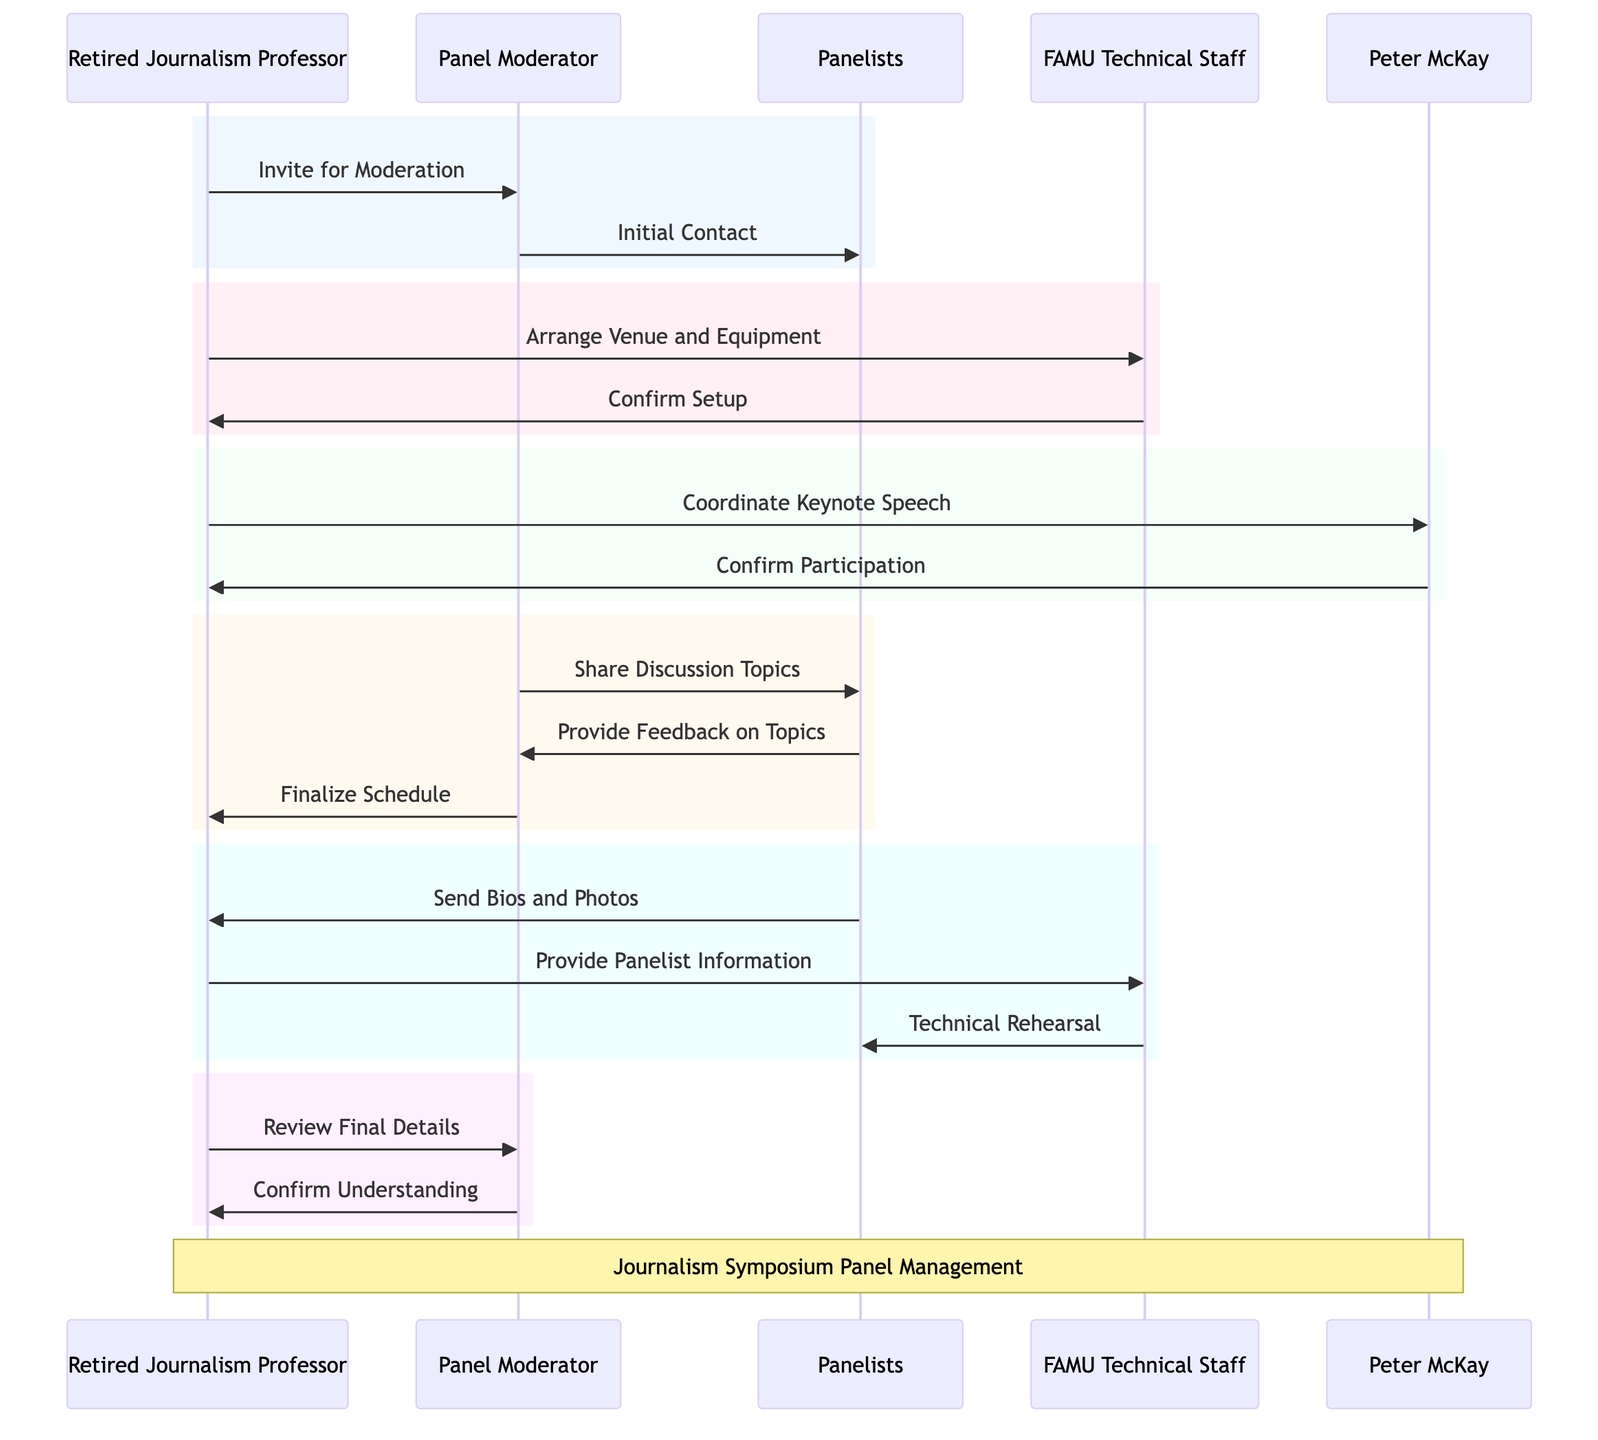What is the role of Peter McKay in the diagram? The diagram indicates that Peter McKay's role is as the Keynote Speaker. This is shown directly in the actor representation within the diagram where each individual's role is clearly stated.
Answer: Keynote Speaker How many participants are involved in the panel discussion? The diagram lists five key actors: Retired Journalism Professor, Panel Moderator, Panelists, FAMU Technical Staff, and Peter McKay. Counting these actors gives a total of five participants.
Answer: Five Who sends the initial contact to the panelists? According to the flow of the diagram, the Panel Moderator is responsible for making the initial contact with the Panelists. This action is shown as a direct message from the Panel Moderator to the Panelists labeled "Initial Contact."
Answer: Panel Moderator What is confirmed after the Retired Journalism Professor coordinates with Peter McKay? Following coordination with Peter McKay, the action labeled "Confirm Participation" indicates that Peter McKay confirms his participation in the symposium. This represents a reciprocal communication after the initial outreach.
Answer: Confirm Participation Which actor is responsible for technical rehearsal? The diagram shows that the FAMU Technical Staff performs the 'Technical Rehearsal' which is represented by a message sent to the Panelists. This indicates their involvement in preparing the technical aspects of the panel.
Answer: FAMU Technical Staff What is the sequence of messages regarding discussion topics? The sequence begins with the Panel Moderator sharing discussion topics with the Panelists, who then provide feedback on those topics. This highlights an interactive approach in managing panelist contributions before finalizing the schedule.
Answer: Share Discussion Topics, Provide Feedback on Topics How many messages are sent from the Retired Journalism Professor to others? In the diagram, the Retired Journalism Professor sends messages to four distinct actors: the Panel Moderator, FAMU Technical Staff, Peter McKay, and the Panelists. Counting these messages yields a total of five sent messages.
Answer: Four What is the final message confirmed in the diagram? The last message in the sequence diagram is "Confirm Understanding," which is sent from the Panel Moderator back to the Retired Journalism Professor. This concludes the interaction between the two actors regarding their roles and responsibilities.
Answer: Confirm Understanding What action follows after sending the bios and photos from the panelists? After the Panelists send their bios and photos to the Retired Journalism Professor, he then provides the panelist information to the FAMU Technical Staff. This step is crucial for ensuring technical arrangements are aligned with the panelist details.
Answer: Provide Panelist Information 